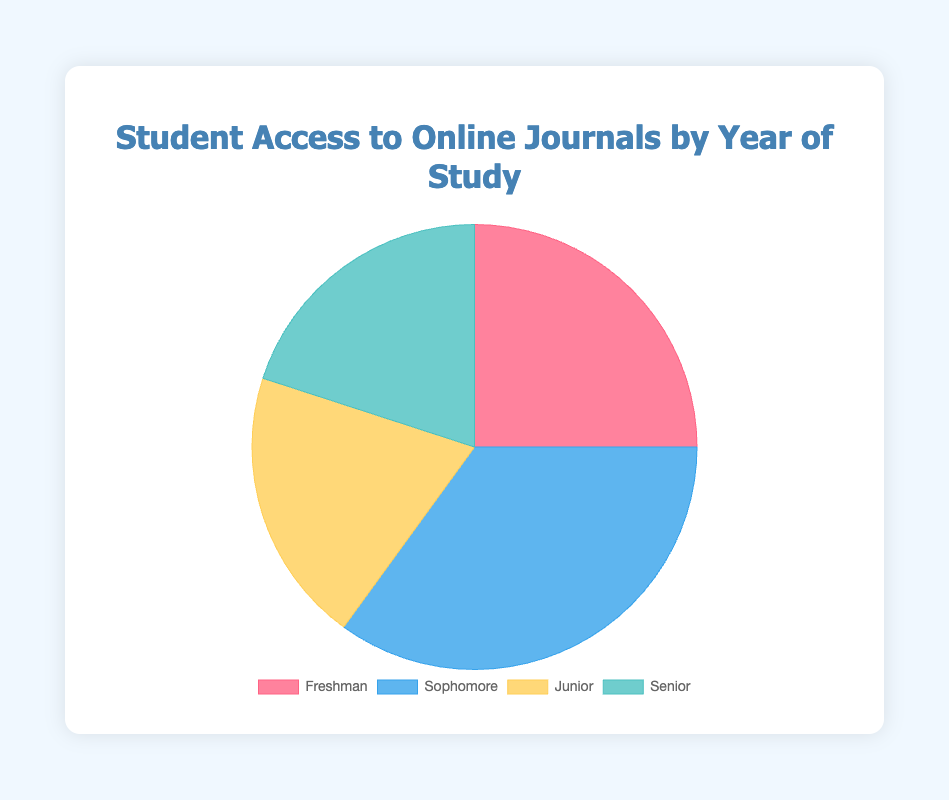What is the total percentage of Junior and Senior students accessing online journals? To find the total percentage, add the percentages of Juniors and Seniors: 20% + 20% = 40%
Answer: 40% Which year of study has the most access to online journals? Compare the percentages: Freshman (25%), Sophomore (35%), Junior (20%), and Senior (20%). The highest percentage is for Sophomores at 35%.
Answer: Sophomore By how much is the Sophomore access greater than the Freshman access? Subtract the Freshman percentage from the Sophomore percentage: 35% - 25% = 10%
Answer: 10% What is the ratio of Freshman access to Senior access? Find the ratio by dividing the Freshman percentage by the Senior percentage: 25% / 20% = 1.25. So, the ratio is 1.25:1
Answer: 1.25:1 What color represents Junior students in the pie chart? Observe the chart legend, noting that Junior students are represented by yellow.
Answer: Yellow How many more percentage points do Sophomores account for compared to Juniors and Seniors combined? First, sum the percentages for Juniors and Seniors: 20% + 20% = 40%. Then, subtract the Sophomore percentage from this total: 40% - 35% = 5%.
Answer: -5% Which group is represented by the red section of the pie chart? The chart legend shows the red section corresponds to Freshman.
Answer: Freshman If we combine Freshman and Junior accesses, how much more is their total access compared to Sophomore access? Sum the percentages for Freshman and Junior: 25% + 20% = 45%. Then, subtract the Sophomore percentage from this total: 45% - 35% = 10%.
Answer: 10% What fraction of the total access do Senior students represent? Senior students make up 20% of the total access. In fraction terms, this is 20/100 or 1/5.
Answer: 1/5 What percentage of total access do Freshman and Seniors combined represent? Add the percentages of Freshman and Seniors: 25% + 20% = 45%
Answer: 45% 